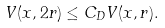<formula> <loc_0><loc_0><loc_500><loc_500>V ( x , 2 r ) \leq C _ { D } V ( x , r ) .</formula> 